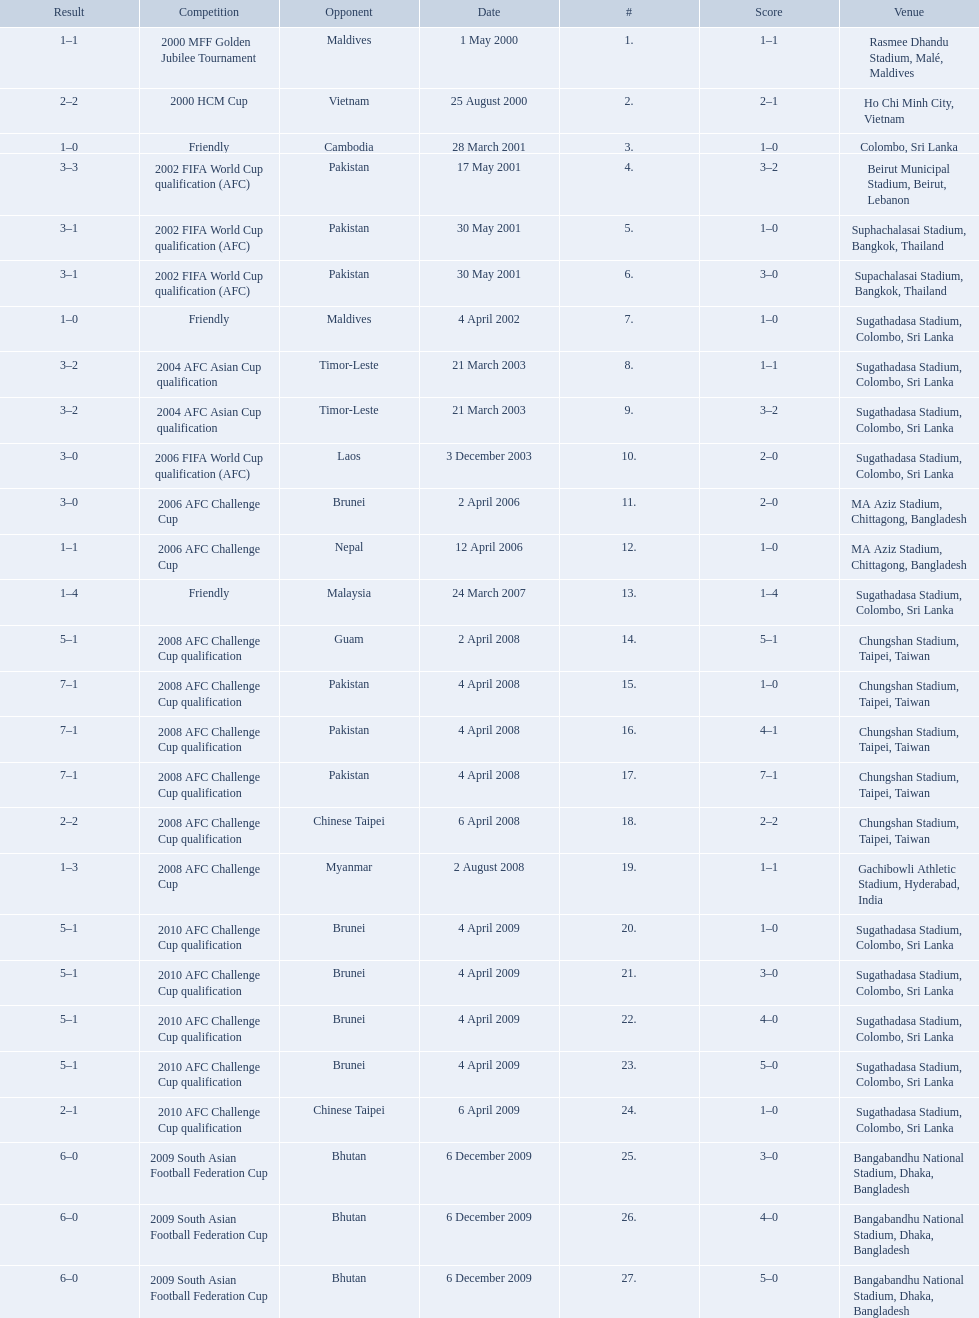Parse the full table in json format. {'header': ['Result', 'Competition', 'Opponent', 'Date', '#', 'Score', 'Venue'], 'rows': [['1–1', '2000 MFF Golden Jubilee Tournament', 'Maldives', '1 May 2000', '1.', '1–1', 'Rasmee Dhandu Stadium, Malé, Maldives'], ['2–2', '2000 HCM Cup', 'Vietnam', '25 August 2000', '2.', '2–1', 'Ho Chi Minh City, Vietnam'], ['1–0', 'Friendly', 'Cambodia', '28 March 2001', '3.', '1–0', 'Colombo, Sri Lanka'], ['3–3', '2002 FIFA World Cup qualification (AFC)', 'Pakistan', '17 May 2001', '4.', '3–2', 'Beirut Municipal Stadium, Beirut, Lebanon'], ['3–1', '2002 FIFA World Cup qualification (AFC)', 'Pakistan', '30 May 2001', '5.', '1–0', 'Suphachalasai Stadium, Bangkok, Thailand'], ['3–1', '2002 FIFA World Cup qualification (AFC)', 'Pakistan', '30 May 2001', '6.', '3–0', 'Supachalasai Stadium, Bangkok, Thailand'], ['1–0', 'Friendly', 'Maldives', '4 April 2002', '7.', '1–0', 'Sugathadasa Stadium, Colombo, Sri Lanka'], ['3–2', '2004 AFC Asian Cup qualification', 'Timor-Leste', '21 March 2003', '8.', '1–1', 'Sugathadasa Stadium, Colombo, Sri Lanka'], ['3–2', '2004 AFC Asian Cup qualification', 'Timor-Leste', '21 March 2003', '9.', '3–2', 'Sugathadasa Stadium, Colombo, Sri Lanka'], ['3–0', '2006 FIFA World Cup qualification (AFC)', 'Laos', '3 December 2003', '10.', '2–0', 'Sugathadasa Stadium, Colombo, Sri Lanka'], ['3–0', '2006 AFC Challenge Cup', 'Brunei', '2 April 2006', '11.', '2–0', 'MA Aziz Stadium, Chittagong, Bangladesh'], ['1–1', '2006 AFC Challenge Cup', 'Nepal', '12 April 2006', '12.', '1–0', 'MA Aziz Stadium, Chittagong, Bangladesh'], ['1–4', 'Friendly', 'Malaysia', '24 March 2007', '13.', '1–4', 'Sugathadasa Stadium, Colombo, Sri Lanka'], ['5–1', '2008 AFC Challenge Cup qualification', 'Guam', '2 April 2008', '14.', '5–1', 'Chungshan Stadium, Taipei, Taiwan'], ['7–1', '2008 AFC Challenge Cup qualification', 'Pakistan', '4 April 2008', '15.', '1–0', 'Chungshan Stadium, Taipei, Taiwan'], ['7–1', '2008 AFC Challenge Cup qualification', 'Pakistan', '4 April 2008', '16.', '4–1', 'Chungshan Stadium, Taipei, Taiwan'], ['7–1', '2008 AFC Challenge Cup qualification', 'Pakistan', '4 April 2008', '17.', '7–1', 'Chungshan Stadium, Taipei, Taiwan'], ['2–2', '2008 AFC Challenge Cup qualification', 'Chinese Taipei', '6 April 2008', '18.', '2–2', 'Chungshan Stadium, Taipei, Taiwan'], ['1–3', '2008 AFC Challenge Cup', 'Myanmar', '2 August 2008', '19.', '1–1', 'Gachibowli Athletic Stadium, Hyderabad, India'], ['5–1', '2010 AFC Challenge Cup qualification', 'Brunei', '4 April 2009', '20.', '1–0', 'Sugathadasa Stadium, Colombo, Sri Lanka'], ['5–1', '2010 AFC Challenge Cup qualification', 'Brunei', '4 April 2009', '21.', '3–0', 'Sugathadasa Stadium, Colombo, Sri Lanka'], ['5–1', '2010 AFC Challenge Cup qualification', 'Brunei', '4 April 2009', '22.', '4–0', 'Sugathadasa Stadium, Colombo, Sri Lanka'], ['5–1', '2010 AFC Challenge Cup qualification', 'Brunei', '4 April 2009', '23.', '5–0', 'Sugathadasa Stadium, Colombo, Sri Lanka'], ['2–1', '2010 AFC Challenge Cup qualification', 'Chinese Taipei', '6 April 2009', '24.', '1–0', 'Sugathadasa Stadium, Colombo, Sri Lanka'], ['6–0', '2009 South Asian Football Federation Cup', 'Bhutan', '6 December 2009', '25.', '3–0', 'Bangabandhu National Stadium, Dhaka, Bangladesh'], ['6–0', '2009 South Asian Football Federation Cup', 'Bhutan', '6 December 2009', '26.', '4–0', 'Bangabandhu National Stadium, Dhaka, Bangladesh'], ['6–0', '2009 South Asian Football Federation Cup', 'Bhutan', '6 December 2009', '27.', '5–0', 'Bangabandhu National Stadium, Dhaka, Bangladesh']]} What are the venues Rasmee Dhandu Stadium, Malé, Maldives, Ho Chi Minh City, Vietnam, Colombo, Sri Lanka, Beirut Municipal Stadium, Beirut, Lebanon, Suphachalasai Stadium, Bangkok, Thailand, Supachalasai Stadium, Bangkok, Thailand, Sugathadasa Stadium, Colombo, Sri Lanka, Sugathadasa Stadium, Colombo, Sri Lanka, Sugathadasa Stadium, Colombo, Sri Lanka, Sugathadasa Stadium, Colombo, Sri Lanka, MA Aziz Stadium, Chittagong, Bangladesh, MA Aziz Stadium, Chittagong, Bangladesh, Sugathadasa Stadium, Colombo, Sri Lanka, Chungshan Stadium, Taipei, Taiwan, Chungshan Stadium, Taipei, Taiwan, Chungshan Stadium, Taipei, Taiwan, Chungshan Stadium, Taipei, Taiwan, Chungshan Stadium, Taipei, Taiwan, Gachibowli Athletic Stadium, Hyderabad, India, Sugathadasa Stadium, Colombo, Sri Lanka, Sugathadasa Stadium, Colombo, Sri Lanka, Sugathadasa Stadium, Colombo, Sri Lanka, Sugathadasa Stadium, Colombo, Sri Lanka, Sugathadasa Stadium, Colombo, Sri Lanka, Bangabandhu National Stadium, Dhaka, Bangladesh, Bangabandhu National Stadium, Dhaka, Bangladesh, Bangabandhu National Stadium, Dhaka, Bangladesh. What are the #'s? 1., 2., 3., 4., 5., 6., 7., 8., 9., 10., 11., 12., 13., 14., 15., 16., 17., 18., 19., 20., 21., 22., 23., 24., 25., 26., 27. Which one is #1? Rasmee Dhandu Stadium, Malé, Maldives. 